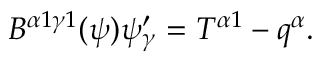<formula> <loc_0><loc_0><loc_500><loc_500>\begin{array} { r } { B ^ { \alpha 1 \gamma 1 } ( \psi ) \psi _ { \gamma } ^ { \prime } = T ^ { \alpha 1 } - q ^ { \alpha } . } \end{array}</formula> 